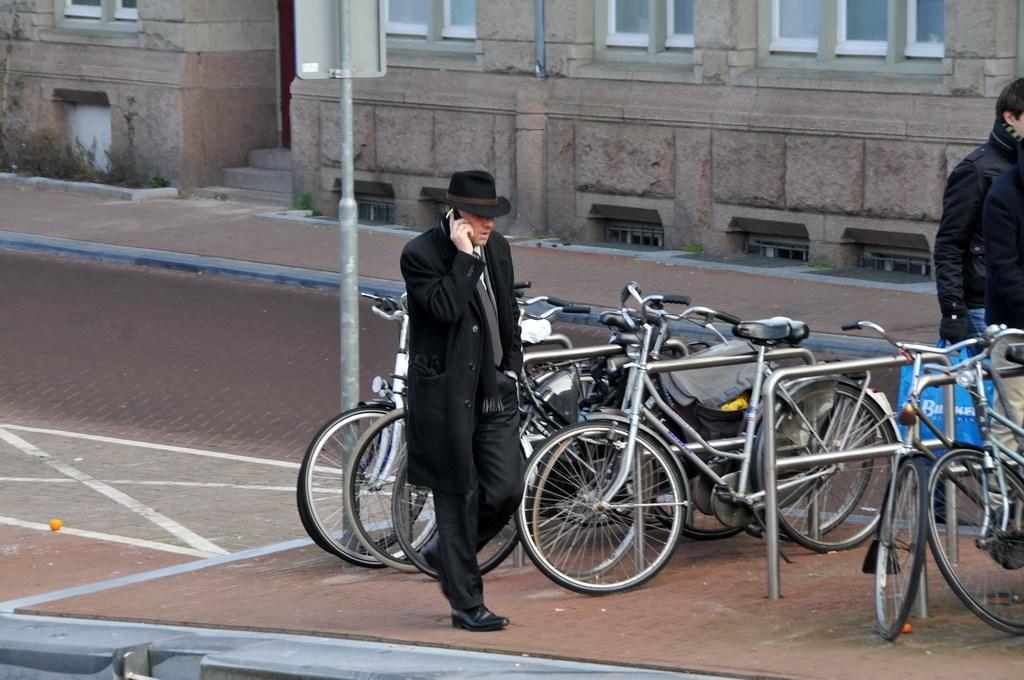Describe this image in one or two sentences. In this picture I can see there is a man walking here and he is wearing a black coat and there are bicycles parked here and there is another man here on to the left. In the backdrop I can see there is a building here and it has some windows and a door. 